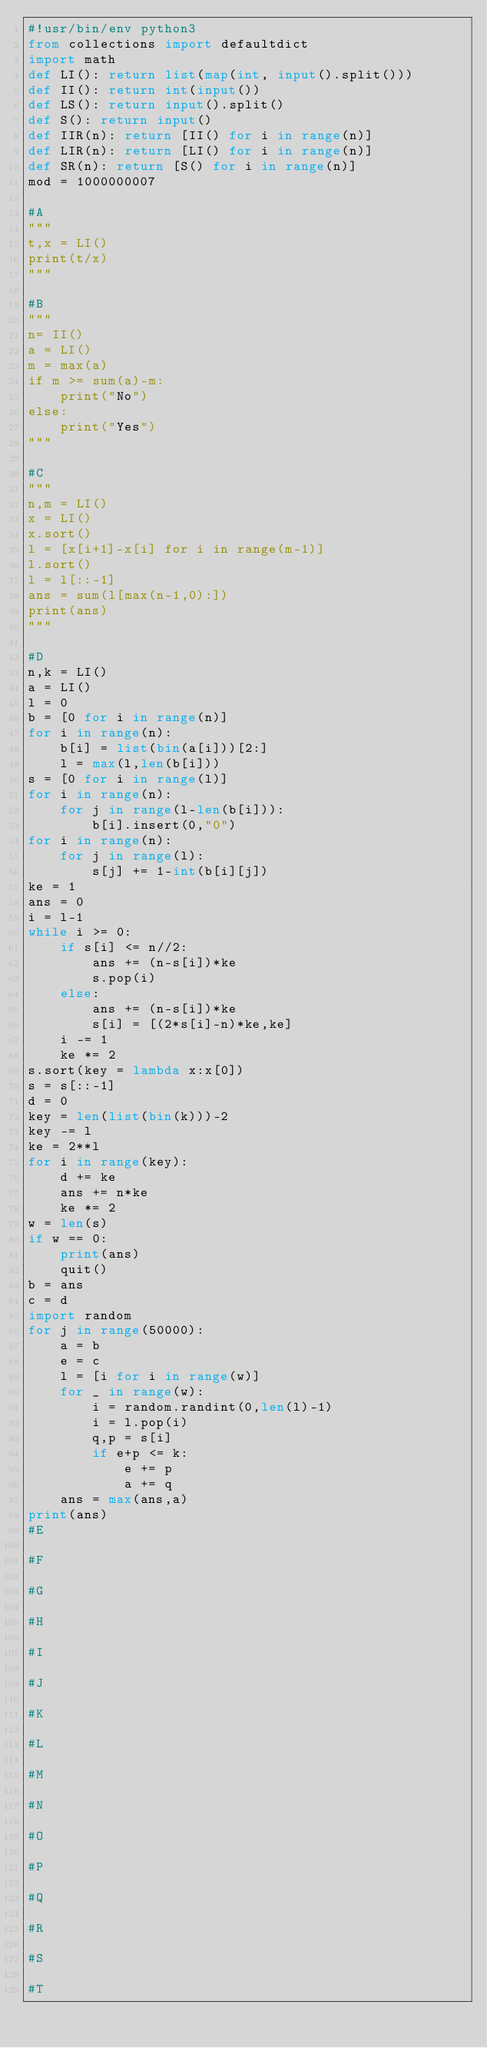Convert code to text. <code><loc_0><loc_0><loc_500><loc_500><_Python_>#!usr/bin/env python3
from collections import defaultdict
import math
def LI(): return list(map(int, input().split()))
def II(): return int(input())
def LS(): return input().split()
def S(): return input()
def IIR(n): return [II() for i in range(n)]
def LIR(n): return [LI() for i in range(n)]
def SR(n): return [S() for i in range(n)]
mod = 1000000007

#A
"""
t,x = LI()
print(t/x)
"""

#B
"""
n= II()
a = LI()
m = max(a)
if m >= sum(a)-m:
    print("No")
else:
    print("Yes")
"""

#C
"""
n,m = LI()
x = LI()
x.sort()
l = [x[i+1]-x[i] for i in range(m-1)]
l.sort()
l = l[::-1]
ans = sum(l[max(n-1,0):])
print(ans)
"""

#D
n,k = LI()
a = LI()
l = 0
b = [0 for i in range(n)]
for i in range(n):
    b[i] = list(bin(a[i]))[2:]
    l = max(l,len(b[i]))
s = [0 for i in range(l)]
for i in range(n):
    for j in range(l-len(b[i])):
        b[i].insert(0,"0")
for i in range(n):
    for j in range(l):
        s[j] += 1-int(b[i][j])
ke = 1
ans = 0
i = l-1
while i >= 0:
    if s[i] <= n//2:
        ans += (n-s[i])*ke
        s.pop(i)
    else:
        ans += (n-s[i])*ke
        s[i] = [(2*s[i]-n)*ke,ke]
    i -= 1
    ke *= 2
s.sort(key = lambda x:x[0])
s = s[::-1]
d = 0
key = len(list(bin(k)))-2
key -= l
ke = 2**l
for i in range(key):
    d += ke
    ans += n*ke
    ke *= 2
w = len(s)
if w == 0:
    print(ans)
    quit()
b = ans
c = d
import random
for j in range(50000):
    a = b
    e = c
    l = [i for i in range(w)]
    for _ in range(w):
        i = random.randint(0,len(l)-1)
        i = l.pop(i)
        q,p = s[i]
        if e+p <= k:
            e += p
            a += q
    ans = max(ans,a)
print(ans)
#E

#F

#G

#H

#I

#J

#K

#L

#M

#N

#O

#P

#Q

#R

#S

#T
</code> 